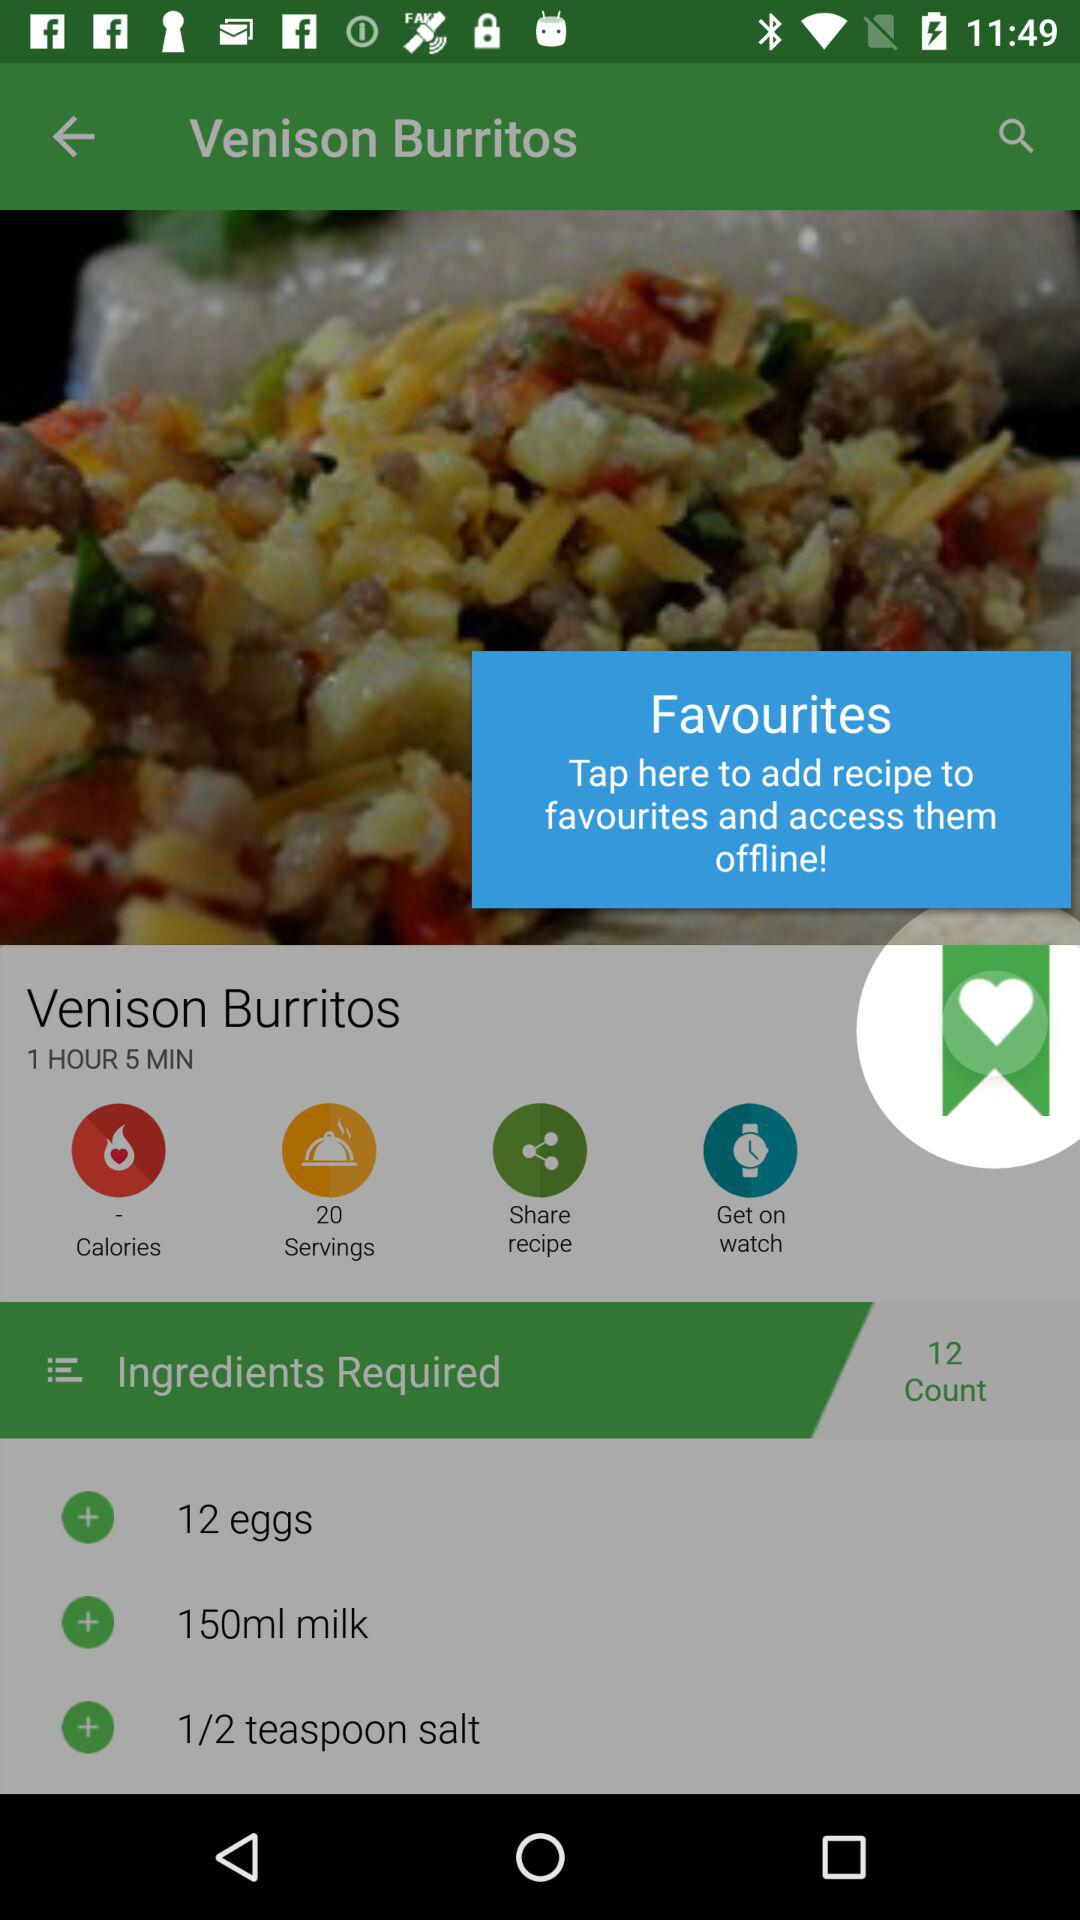What's the duration of making "Venison Burritos"? The duration is 1 hour 5 minutes. 